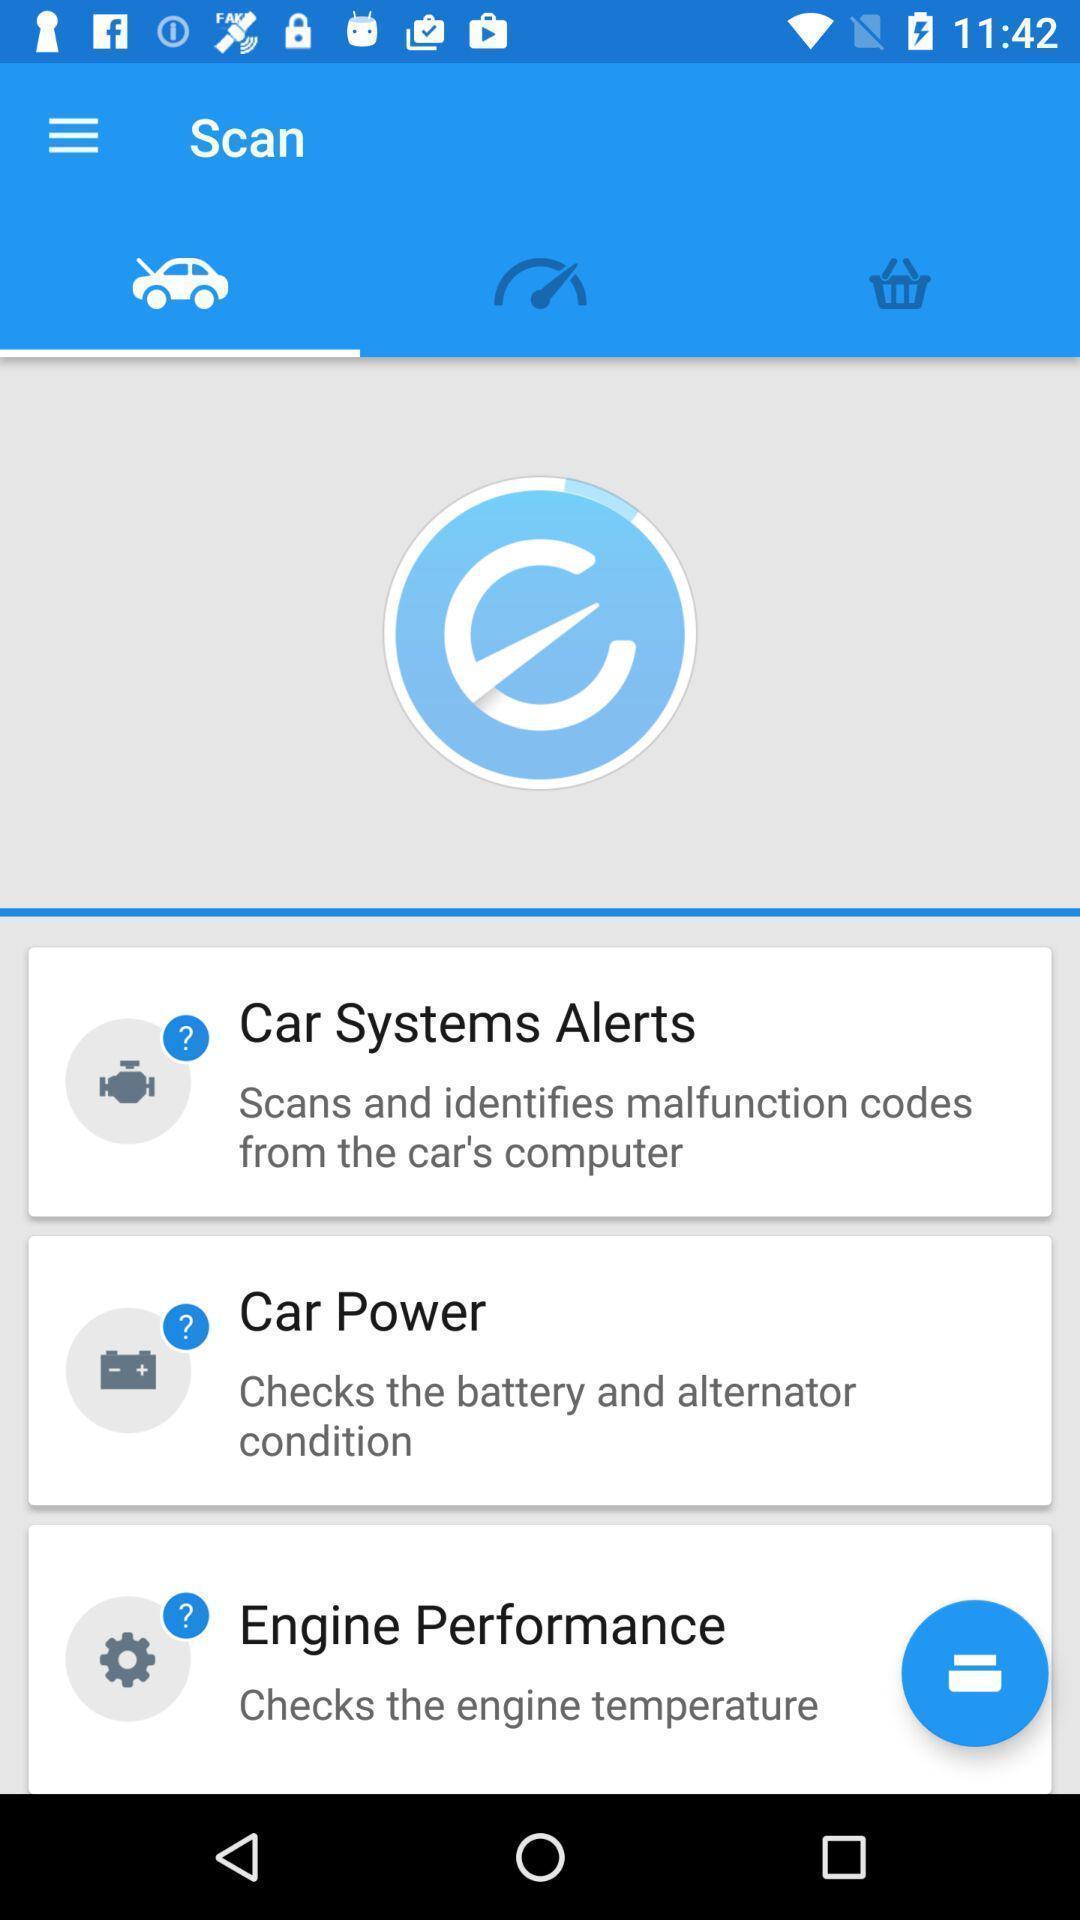Describe the content in this image. Screen displaying the scanning page. 